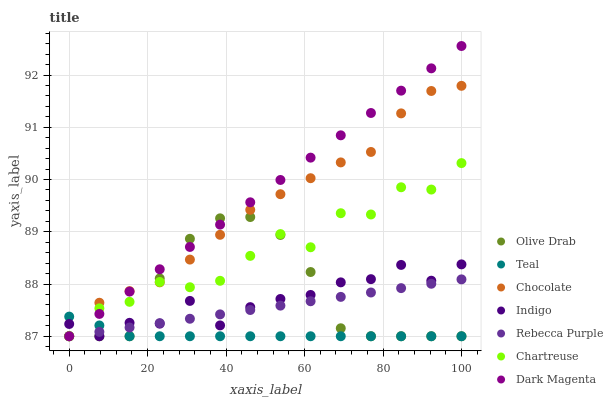Does Teal have the minimum area under the curve?
Answer yes or no. Yes. Does Dark Magenta have the maximum area under the curve?
Answer yes or no. Yes. Does Chocolate have the minimum area under the curve?
Answer yes or no. No. Does Chocolate have the maximum area under the curve?
Answer yes or no. No. Is Rebecca Purple the smoothest?
Answer yes or no. Yes. Is Chartreuse the roughest?
Answer yes or no. Yes. Is Dark Magenta the smoothest?
Answer yes or no. No. Is Dark Magenta the roughest?
Answer yes or no. No. Does Indigo have the lowest value?
Answer yes or no. Yes. Does Dark Magenta have the highest value?
Answer yes or no. Yes. Does Chocolate have the highest value?
Answer yes or no. No. Does Rebecca Purple intersect Olive Drab?
Answer yes or no. Yes. Is Rebecca Purple less than Olive Drab?
Answer yes or no. No. Is Rebecca Purple greater than Olive Drab?
Answer yes or no. No. 